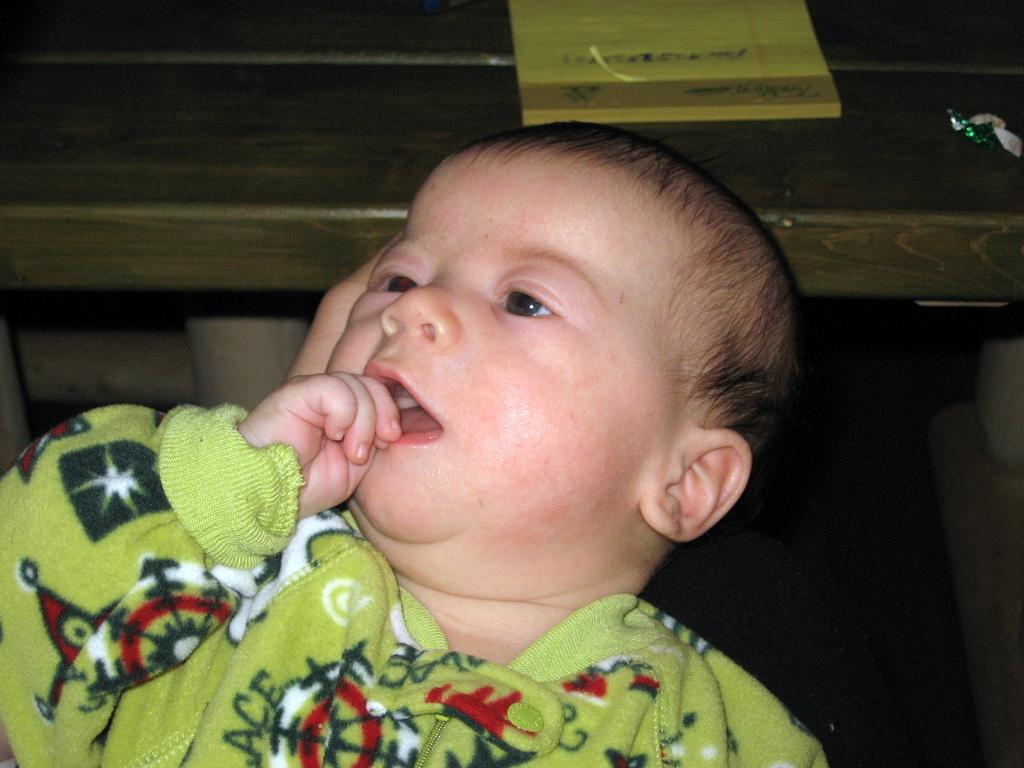What is the main subject of the image? There is a baby in the image. What is the baby wearing? The baby is wearing a green dress. What other object can be seen in the image? There is a table in the image. What is placed on the table? A book is placed on the table. Where is the airport located in the image? There is no airport present in the image. 